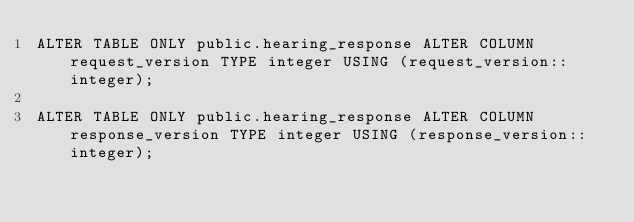Convert code to text. <code><loc_0><loc_0><loc_500><loc_500><_SQL_>ALTER TABLE ONLY public.hearing_response ALTER COLUMN request_version TYPE integer USING (request_version::integer);

ALTER TABLE ONLY public.hearing_response ALTER COLUMN response_version TYPE integer USING (response_version::integer);
</code> 